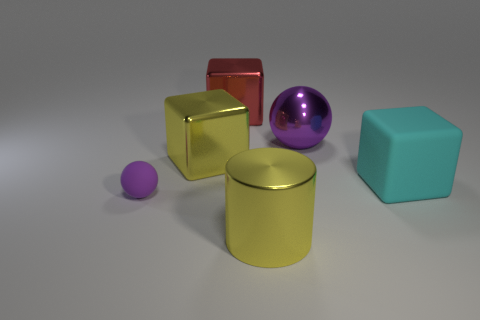What textures are visible among the objects in the image? The objects in the image display a variety of textures. The spheres and the cubes feature smooth and reflective surfaces, whereas the cylinder has a slightly matte finish that reflects less light, giving it a more subdued appearance. 